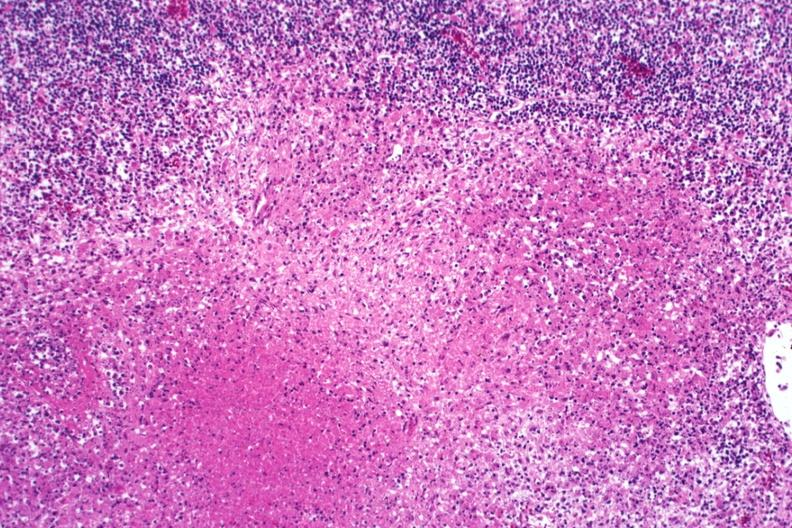s amputation stump infected present?
Answer the question using a single word or phrase. No 